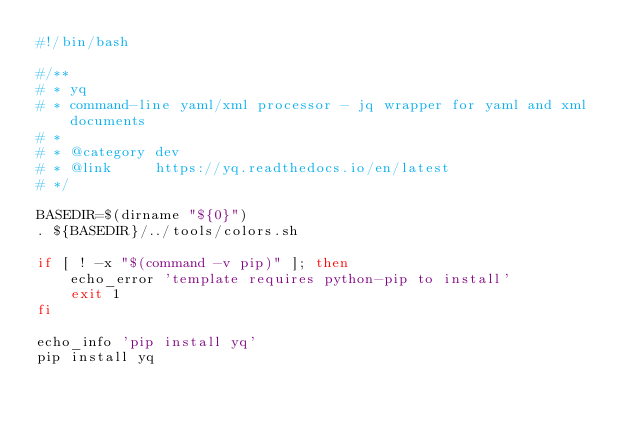<code> <loc_0><loc_0><loc_500><loc_500><_Bash_>#!/bin/bash

#/**
# * yq
# * command-line yaml/xml processor - jq wrapper for yaml and xml documents
# *
# * @category dev
# * @link     https://yq.readthedocs.io/en/latest
# */

BASEDIR=$(dirname "${0}")
. ${BASEDIR}/../tools/colors.sh

if [ ! -x "$(command -v pip)" ]; then
    echo_error 'template requires python-pip to install'
    exit 1
fi

echo_info 'pip install yq'
pip install yq
</code> 